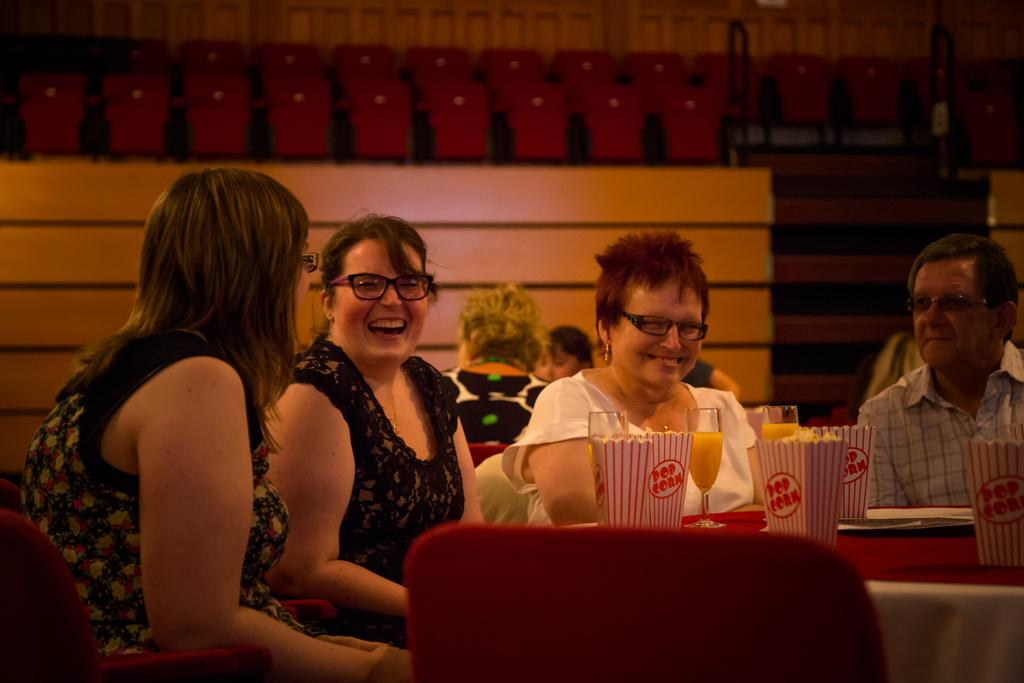How many people are present in the image? There are four people in the image. What are the people doing in the image? The people are sitting on chairs. Where are the chairs located in relation to the table? The chairs are in front of a table. What is the facial expression of the people in the image? The people are smiling. Can you describe the presence of other people in the image? There are other people visible in the background of the image. What type of glue is being used by the people in the image? There is no glue present in the image; the people are sitting on chairs and smiling. What songs are the people singing in the image? There is no indication in the image that the people are singing songs. 